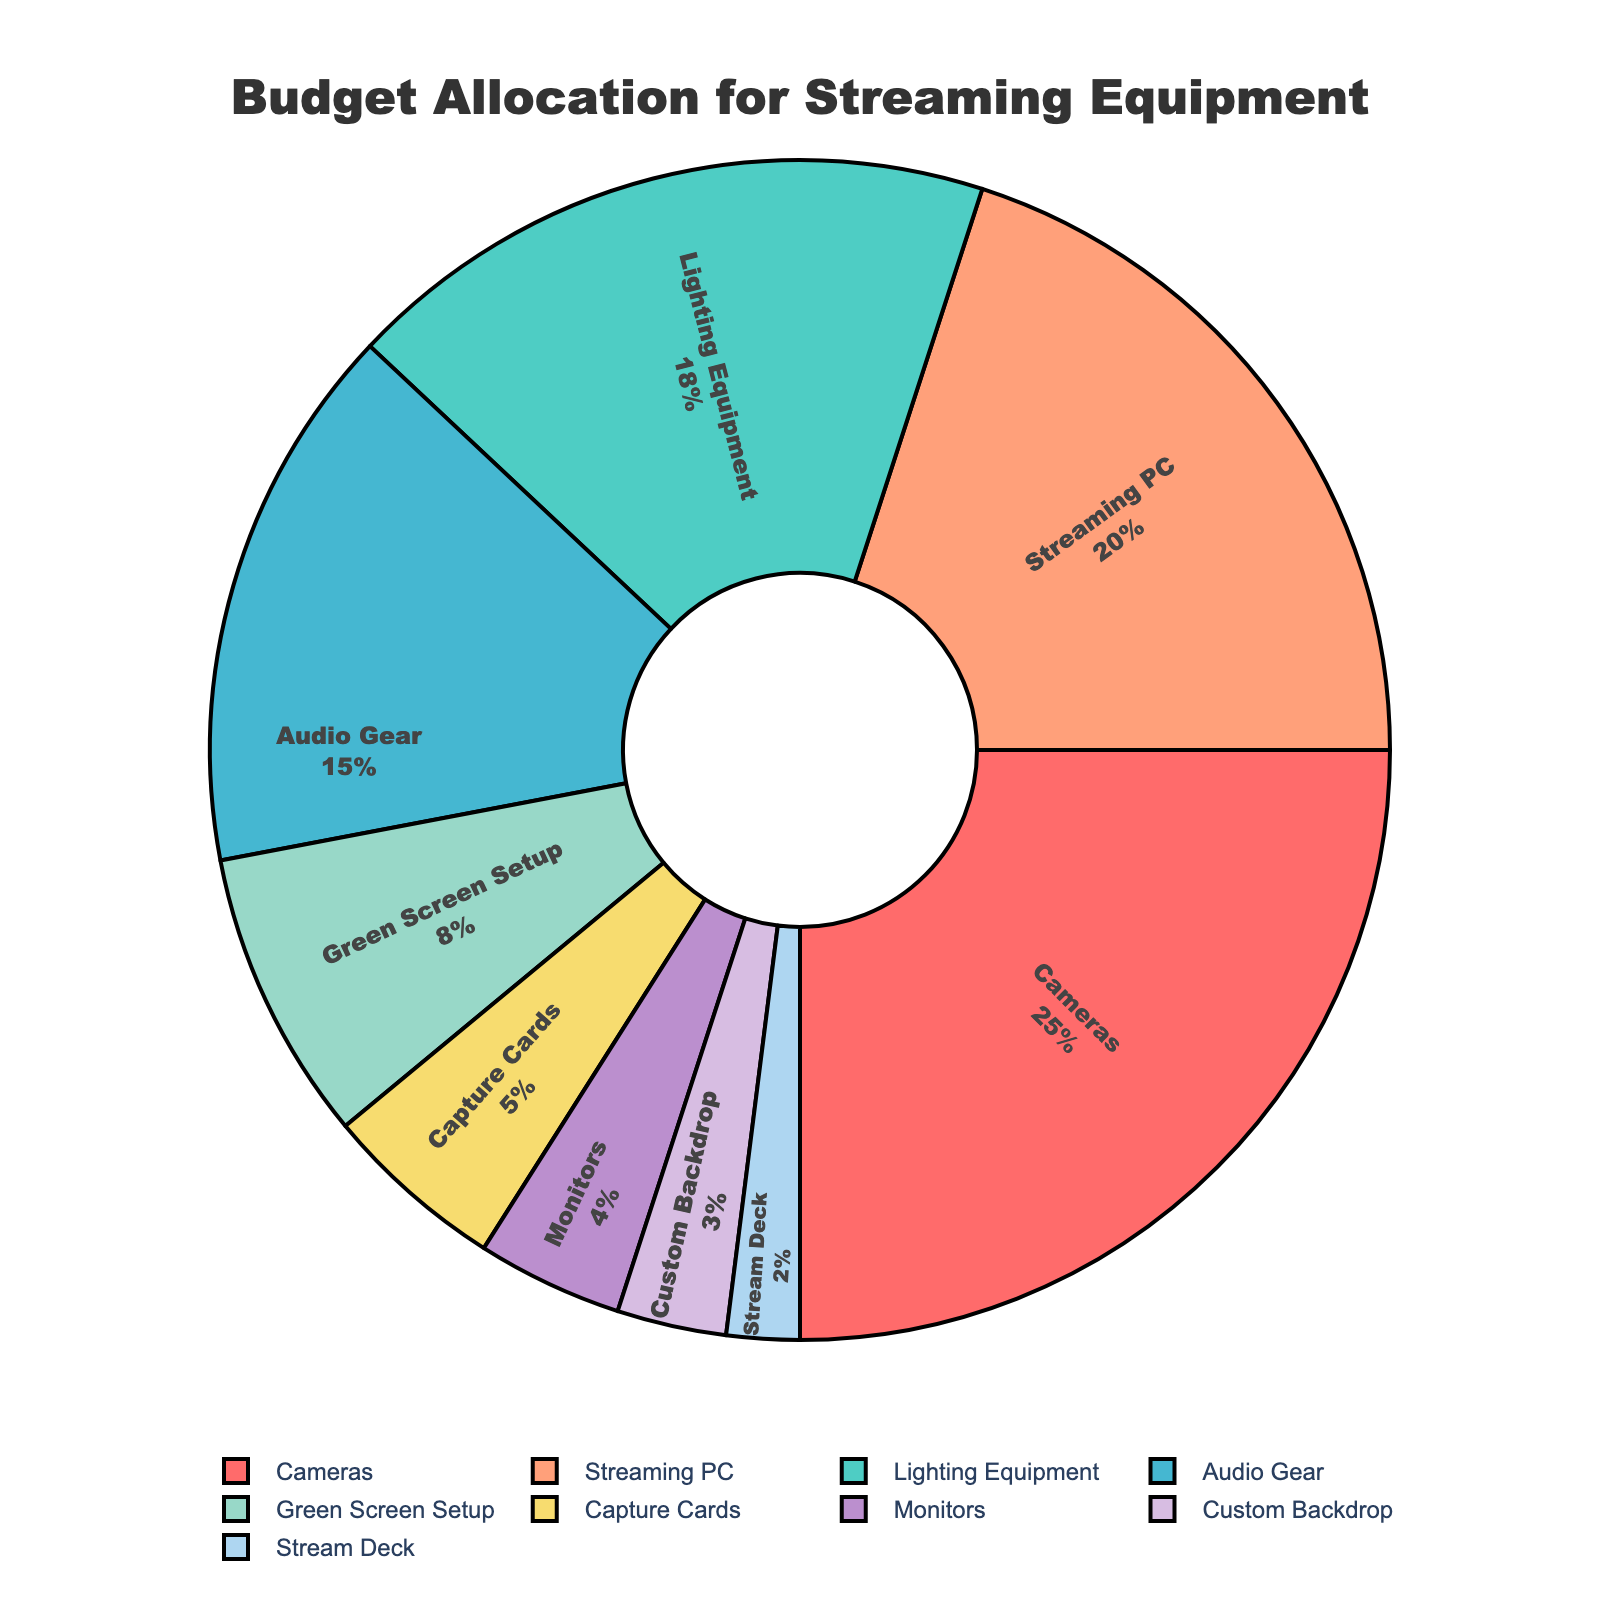What's the largest budget category? To find the largest budget category, we look for the slice with the highest percentage value. The "Cameras" category has the largest slice at 25%.
Answer: Cameras How much of the budget is allocated to combined audio gear and lighting equipment? Add the percentages for "Audio Gear" and "Lighting Equipment." Audio Gear is 15% and Lighting Equipment is 18%, so 15% + 18% = 33%.
Answer: 33% What is the difference in budget percentage between Streaming PC and Capture Cards? Subtract the percentage of "Capture Cards" from the percentage of "Streaming PC." Streaming PC is 20% and Capture Cards is 5%, so 20% - 5% = 15%.
Answer: 15% Which category has a smaller percentage than Monitors but larger than Stream Deck? Identify the categories where the percentage is less than Monitors (4%) and greater than Stream Deck (2%). The "Custom Backdrop" category fits this criterion at 3%.
Answer: Custom Backdrop What percentage of the budget is allocated to both Cameras and Streaming PC together? Add the percentages for "Cameras" and "Streaming PC." Cameras is 25% and Streaming PC is 20%, so 25% + 20% = 45%.
Answer: 45% Is the percentage allocation for Green Screen Setup closer to that for Capture Cards or Monitors? Compare the percentage of "Green Screen Setup" to both "Capture Cards" and "Monitors." Green Screen Setup is 8%, Capture Cards is 5%, and Monitors is 4%. The difference is 8% - 5% = 3% with Capture Cards, and 8% - 4% = 4% with Monitors, so it is closer to Capture Cards.
Answer: Capture Cards Are there more categories with a budget under 5% or above 15%? Count the categories under 5% (Monitors, Custom Backdrop, Stream Deck) that total 3, and count those above 15% (Cameras, Lighting Equipment) that total 2.
Answer: Under 5% Which budget categories are represented with cool colors (like green or blue)? Identify the categories with cool colors by visual inspection. "Lighting Equipment" is green and "Streaming PC" is blue.
Answer: Lighting Equipment, Streaming PC What is the total budget percentage for categories under 10%? Add the percentages for "Green Screen Setup" (8%), "Capture Cards" (5%), "Monitors" (4%), "Custom Backdrop" (3%), and "Stream Deck" (2%). Thus, 8% + 5% + 4% + 3% + 2% = 22%.
Answer: 22% How does the percentage for Lighting Equipment compare to that for Stream Deck? Compare the percentages. Lighting Equipment is 18% and Stream Deck is 2%, with Lighting Equipment being 16% higher.
Answer: 16% higher 